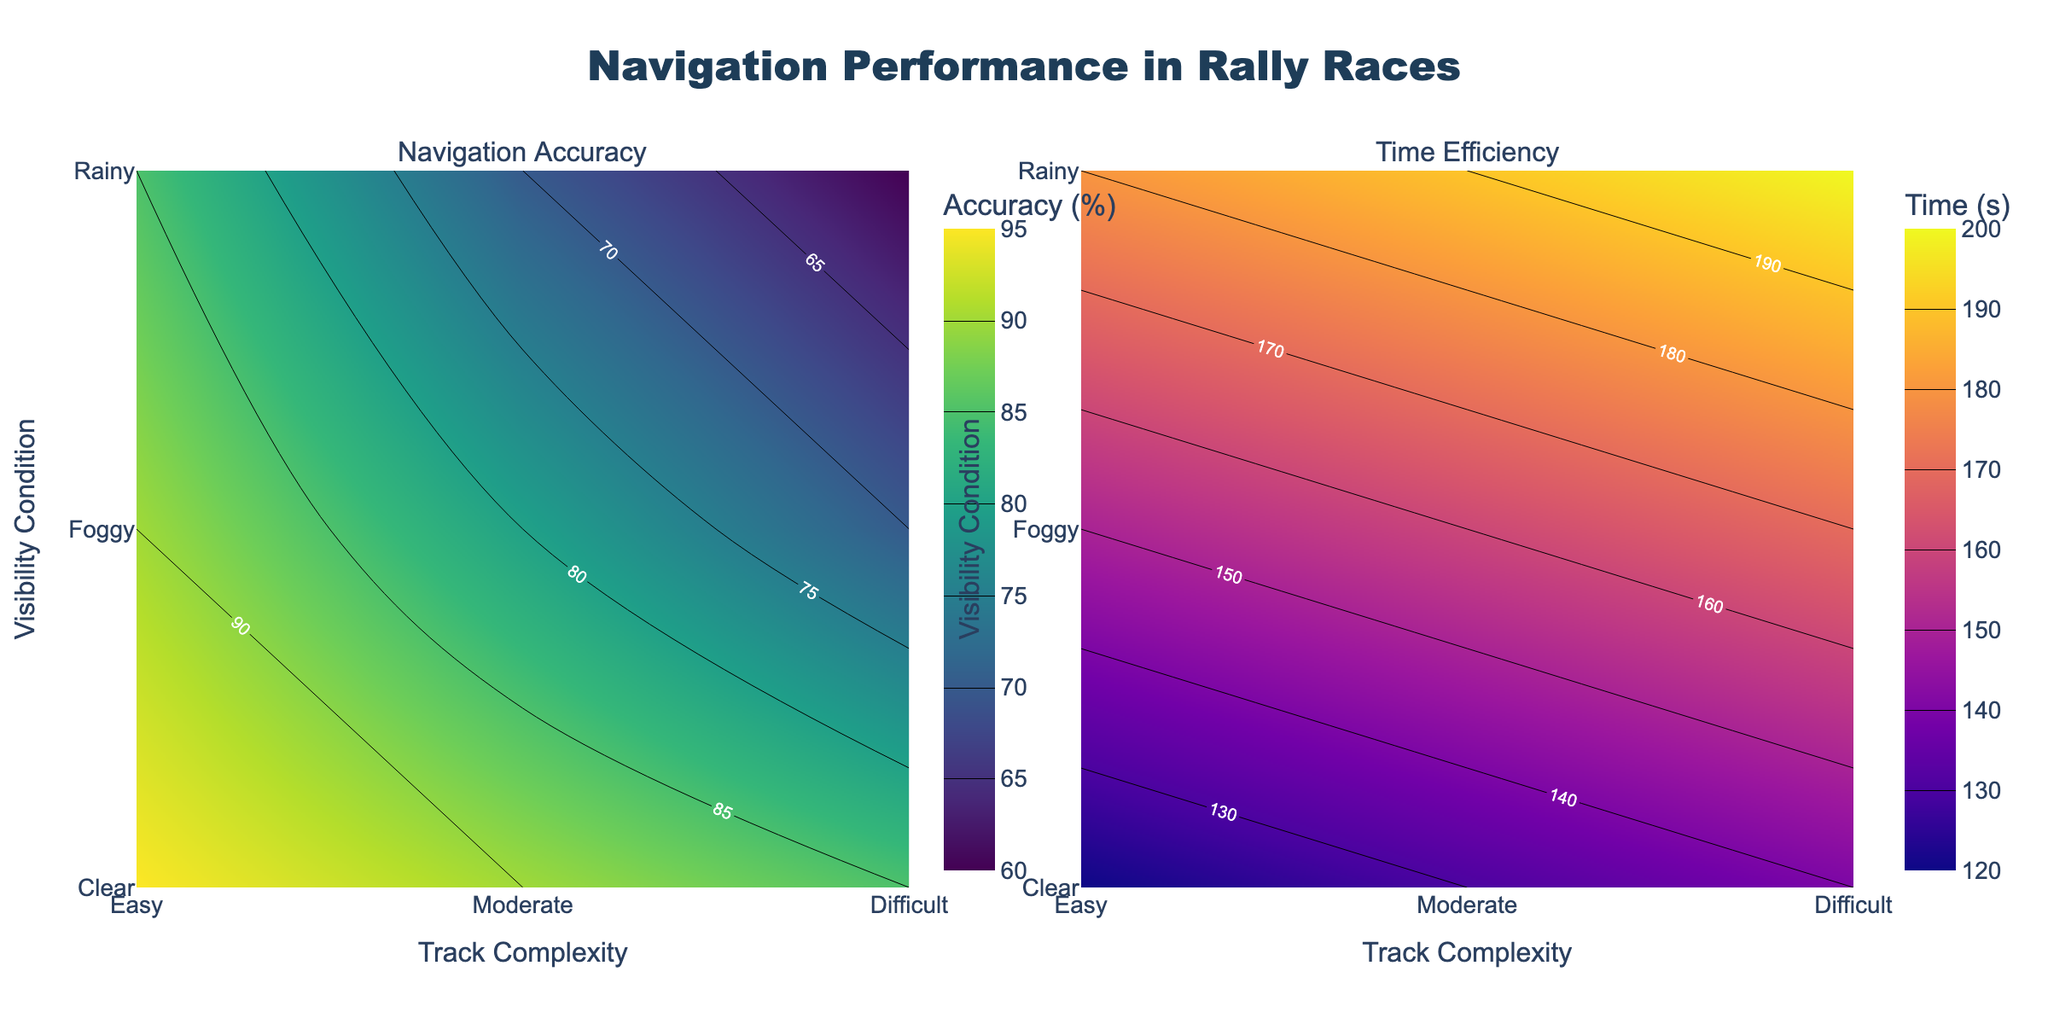What does the title of the figure indicate about the data? The title "Navigation Performance in Rally Races" suggests that the figure concerns the analysis of navigation accuracy and time efficiency in rally races under different track complexities and visibility conditions.
Answer: Navigation Performance in Rally Races What are the axis labels for the figure? The X-axes are labeled "Track Complexity" and the Y-axes are labeled "Visibility Condition" for both subplots in the figure.
Answer: Track Complexity, Visibility Condition Which track complexity and visibility condition combination results in the highest mean navigation accuracy? According to the left subplot, the highest mean navigation accuracy occurs for the "Easy" track under "Clear" visibility conditions.
Answer: Easy, Clear How does the mean navigation accuracy change as the visibility condition deteriorates for an "Easy" track? For an "Easy" track, mean navigation accuracy decreases as the visibility conditions change from Clear (95%) to Foggy (90%) to Rainy (85%).
Answer: Decreases Under which conditions is the mean time efficiency the worst? From the right subplot, the worst (highest) mean time efficiency is observed for "Difficult" tracks under "Rainy" conditions.
Answer: Difficult, Rainy Compare the mean navigation accuracy between "Moderate" and "Difficult" tracks under "Rainy" conditions? In "Rainy" conditions, the mean navigation accuracy is 70% for "Moderate" tracks and 60% for "Difficult" tracks, so the accuracy is 10% higher for "Moderate".
Answer: Moderate tracks have 10% higher accuracy What is the effect of track complexity on time efficiency under "Clear" visibility? Under "Clear" visibility, mean time efficiency increases with track complexity: Easy (120s), Moderate (150s), and Difficult (180s).
Answer: Increases with track complexity Does the time efficiency change significantly under foggy conditions as the track complexity increases? Yes, the mean time efficiency increases from 130s (Easy), 160s (Moderate), to 190s (Difficult) under foggy conditions, indicating a significant change.
Answer: Increases significantly By how much does the mean navigation accuracy drop from "Clear" to "Rainy" conditions on a "Moderate" track? The accuracy drops from 90% (Clear) to 70% (Rainy) on a Moderate track, resulting in a drop of 20%.
Answer: 20% Based on the contour colors, which subplot shows the lowest values and what does it imply? The right subplot (Time Efficiency) shows the lowest values (darker colors in Plasma colorscale), implying better (lower) time efficiency values compared to other parts of the plot and conditions.
Answer: Time Efficiency subplot shows lower values 